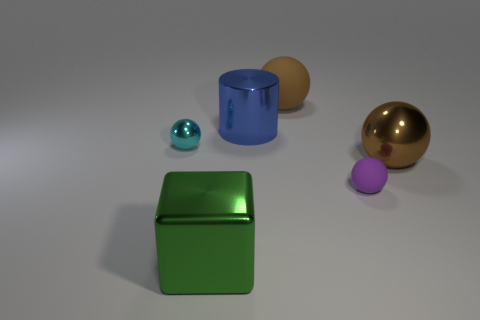Are there any big metal objects behind the matte sphere that is in front of the cylinder?
Keep it short and to the point. Yes. How many spheres are either big green shiny things or blue things?
Make the answer very short. 0. How big is the metal sphere that is right of the shiny object that is in front of the big sphere on the right side of the big brown rubber ball?
Offer a very short reply. Large. Are there any brown metal things to the left of the large brown shiny ball?
Provide a succinct answer. No. The metallic object that is the same color as the big matte thing is what shape?
Your answer should be very brief. Sphere. How many things are either shiny spheres that are in front of the small shiny object or brown matte things?
Ensure brevity in your answer.  2. The brown object that is made of the same material as the tiny purple thing is what size?
Your response must be concise. Large. There is a green block; is its size the same as the brown sphere in front of the big cylinder?
Your answer should be compact. Yes. The large thing that is both in front of the small cyan object and to the right of the large green metal block is what color?
Provide a short and direct response. Brown. How many objects are brown objects that are in front of the small shiny thing or small objects that are in front of the brown metal ball?
Offer a very short reply. 2. 